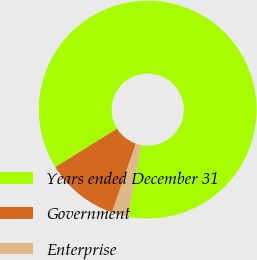Convert chart. <chart><loc_0><loc_0><loc_500><loc_500><pie_chart><fcel>Years ended December 31<fcel>Government<fcel>Enterprise<nl><fcel>86.81%<fcel>10.82%<fcel>2.37%<nl></chart> 